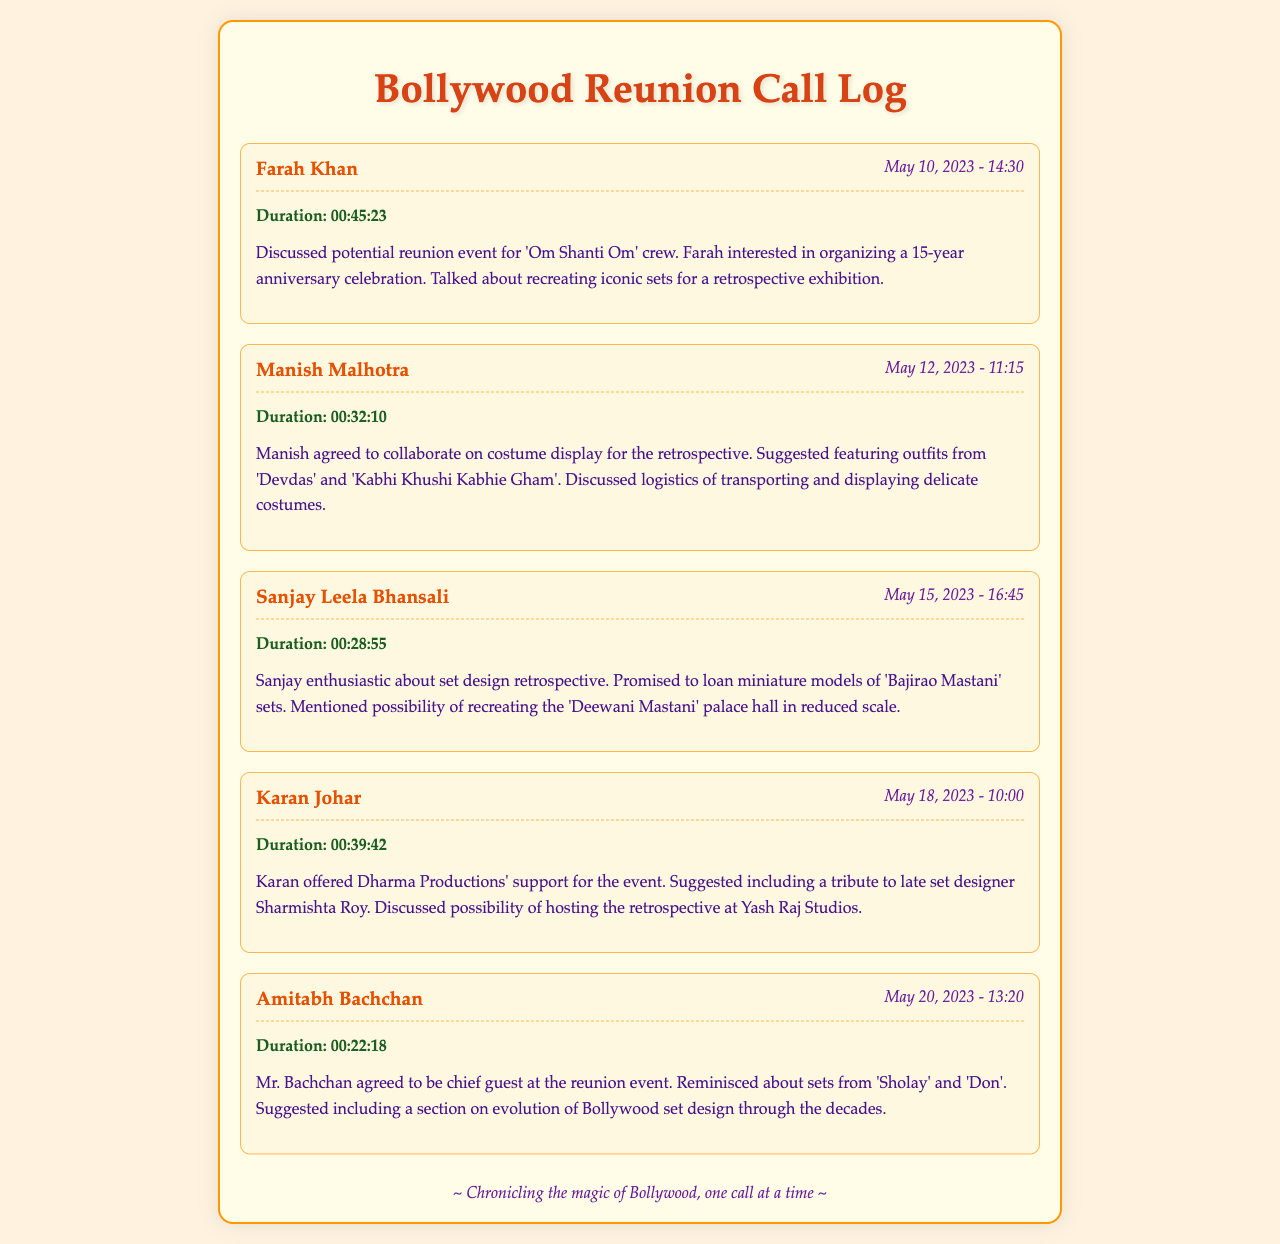What was the date of the call with Farah Khan? The date of the call is specifically mentioned in the call record with Farah Khan as May 10, 2023.
Answer: May 10, 2023 Who suggested including a tribute to late set designer Sharmishta Roy? The call record with Karan Johar indicates that he suggested including this tribute during their conversation.
Answer: Karan Johar What duration did the call with Amitabh Bachchan last? The duration is noted in the call log with Amitabh Bachchan, which lasted 22 minutes and 18 seconds.
Answer: 00:22:18 Which sets did Mr. Bachchan reminisce about during his call? The reminiscence about sets is detailed in the call record with Amitabh Bachchan where he mentions 'Sholay' and 'Don'.
Answer: 'Sholay' and 'Don' What did Sanjay Leela Bhansali promise to loan? The call record with Sanjay Leela Bhansali specifies that he promised to loan miniature models of sets from 'Bajirao Mastani'.
Answer: Miniature models of 'Bajirao Mastani' sets Which iconic film's crew reunion were potential plans discussed? The discussions in the call log indicate that the potential reunion event was for the crew of 'Om Shanti Om'.
Answer: 'Om Shanti Om' What was agreed upon with Manish Malhotra? The call with Manish Malhotra states that he agreed to collaborate on the costume display for the retrospective.
Answer: Collaborate on costume display Where was the retrospective event suggested to be hosted? The document indicates that Karan Johar discussed the possibility of hosting the retrospective at Yash Raj Studios.
Answer: Yash Raj Studios 